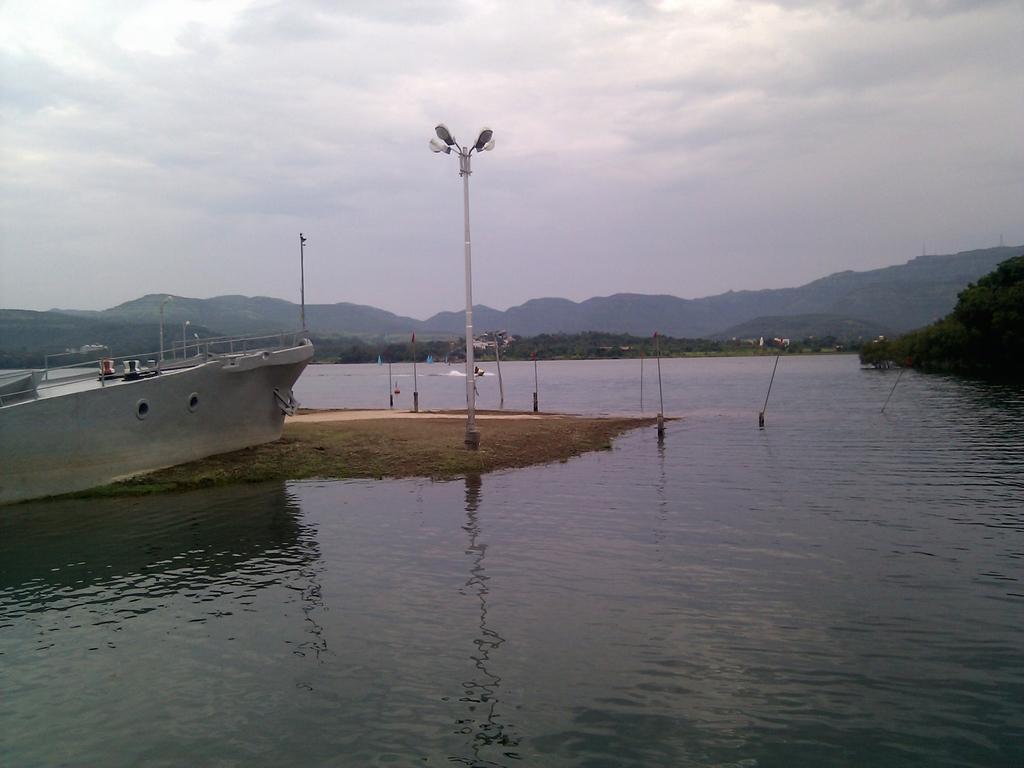Describe this image in one or two sentences. This is the picture of a place where we have a river and around there are some mountains, trees, plants, boat and a pole which has some lights. 